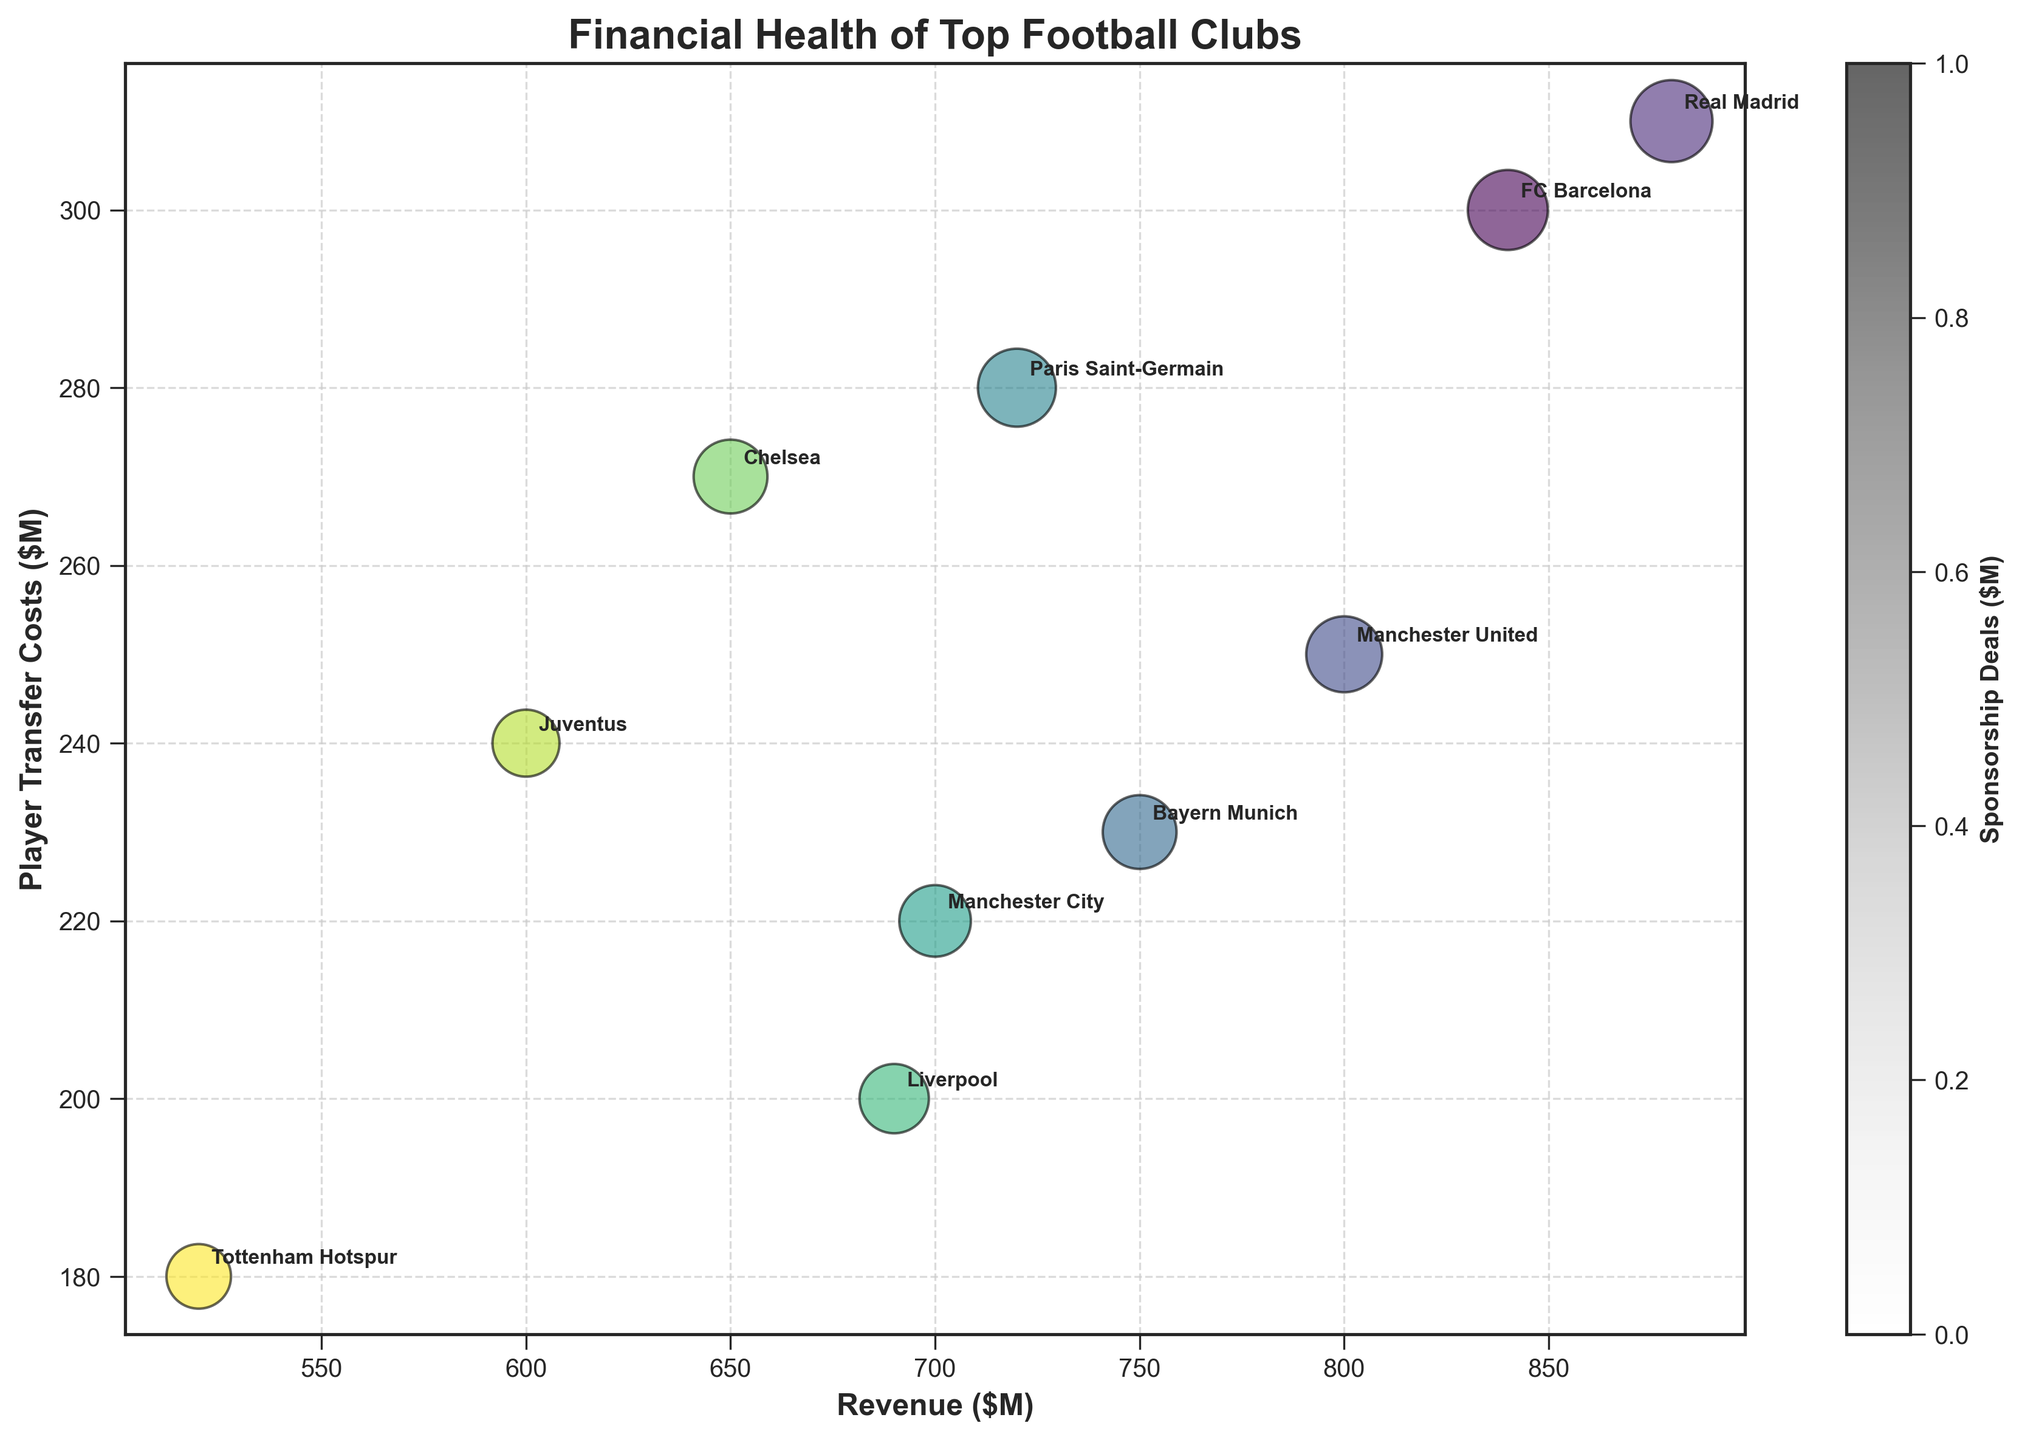What is the title of the chart? The title is placed at the top of the chart. You can read it directly to understand the main focus of the plot.
Answer: Financial Health of Top Football Clubs How many clubs are represented in the chart? Count the number of different clubs annotated on the chart. Each club is labeled next to a bubble.
Answer: 10 Which club has the highest revenue? Look at the x-axis which represents 'Revenue ($M)' and find the club whose bubble is furthest to the right.
Answer: Real Madrid Which club has the smallest bubble size? Observe the size of the bubbles and identify the smallest one. The bubble size represents the 'Bubble Size' from the data.
Answer: Tottenham Hotspur What is the range of player transfer costs? Look at the y-axis, which displays 'Player Transfer Costs ($M)'. Find the minimum and maximum values among the points.
Answer: 180 - 310 How do Bayern Munich's revenue and player transfer costs compare to those of Juventus? Locate the bubbles for Bayern Munich and Juventus, then compare their positions on the x-axis (revenue) and y-axis (player transfer costs).
Answer: Bayern Munich has 750M revenue and 230M player transfer costs; Juventus has 600M revenue and 240M player transfer costs Which club has the highest value in sponsorship deals and what is it? The color bar represents 'Sponsorship Deals ($M)'. Identify the club with the darkest color and read its sponsorship deal value from the color bar.
Answer: Manchester City, 220M What is the average revenue of the clubs shown? Sum the revenues of all clubs and divide by the number of clubs. (840+880+800+750+720+700+690+650+600+520) / 10 = 7150 / 10
Answer: 715M Which clubs have higher player transfer costs than Paris Saint-Germain and how many are there? Check the y-axis value for Paris Saint-Germain (280M), then count the number of clubs with a higher y-value.
Answer: Real Madrid (310M), 1 club What is the correlation between revenue and player transfer costs? Observe the overall trend in the scatter plot – as one increases, does the other tend to increase as well?
Answer: Positive correlation 